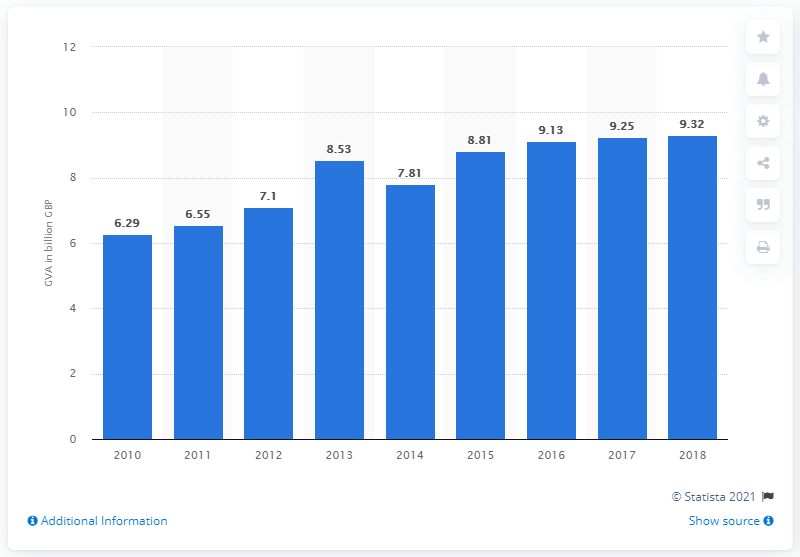Point out several critical features in this image. In 2018, the gross value added of the music, performing and visual arts industry in the UK was 9.32 billion pounds. 